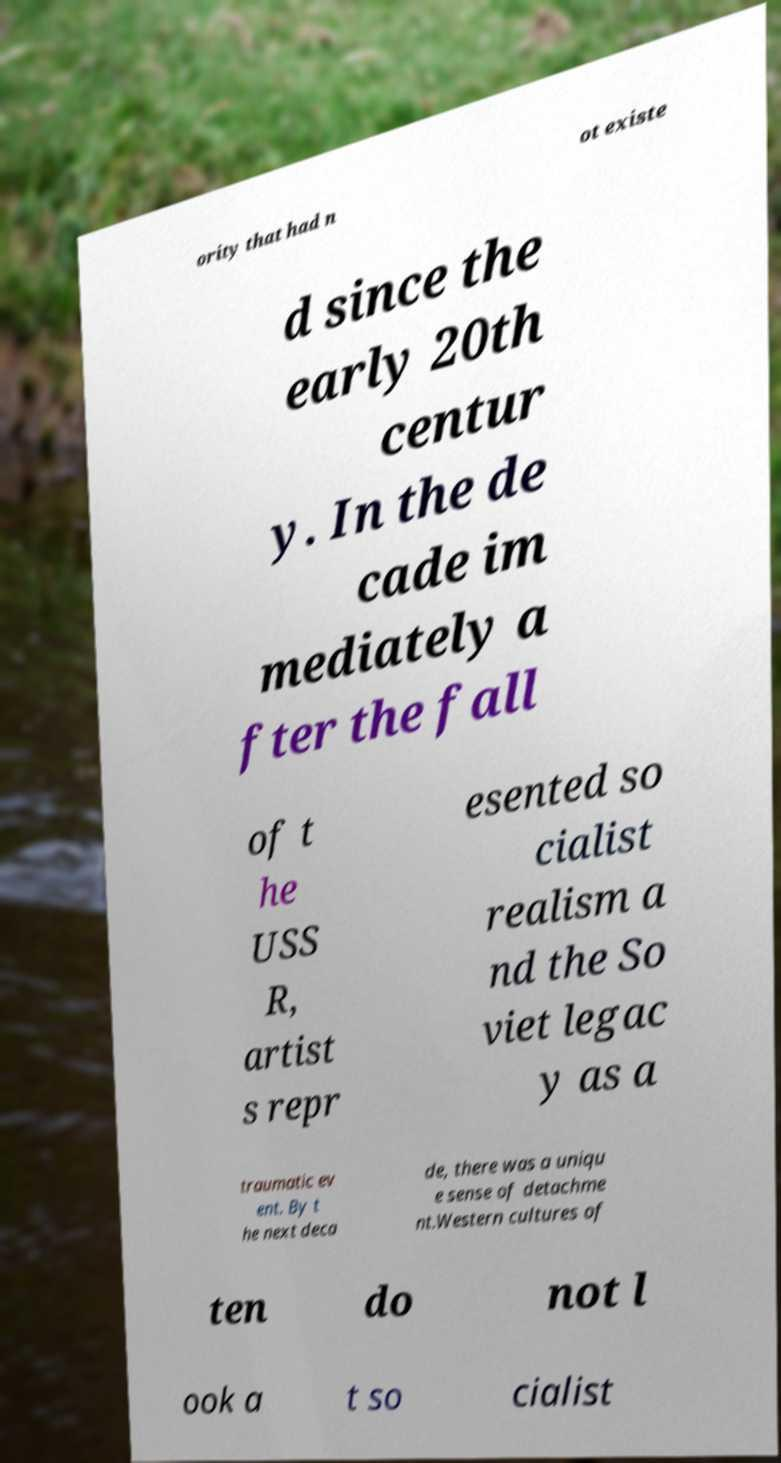Can you read and provide the text displayed in the image?This photo seems to have some interesting text. Can you extract and type it out for me? ority that had n ot existe d since the early 20th centur y. In the de cade im mediately a fter the fall of t he USS R, artist s repr esented so cialist realism a nd the So viet legac y as a traumatic ev ent. By t he next deca de, there was a uniqu e sense of detachme nt.Western cultures of ten do not l ook a t so cialist 